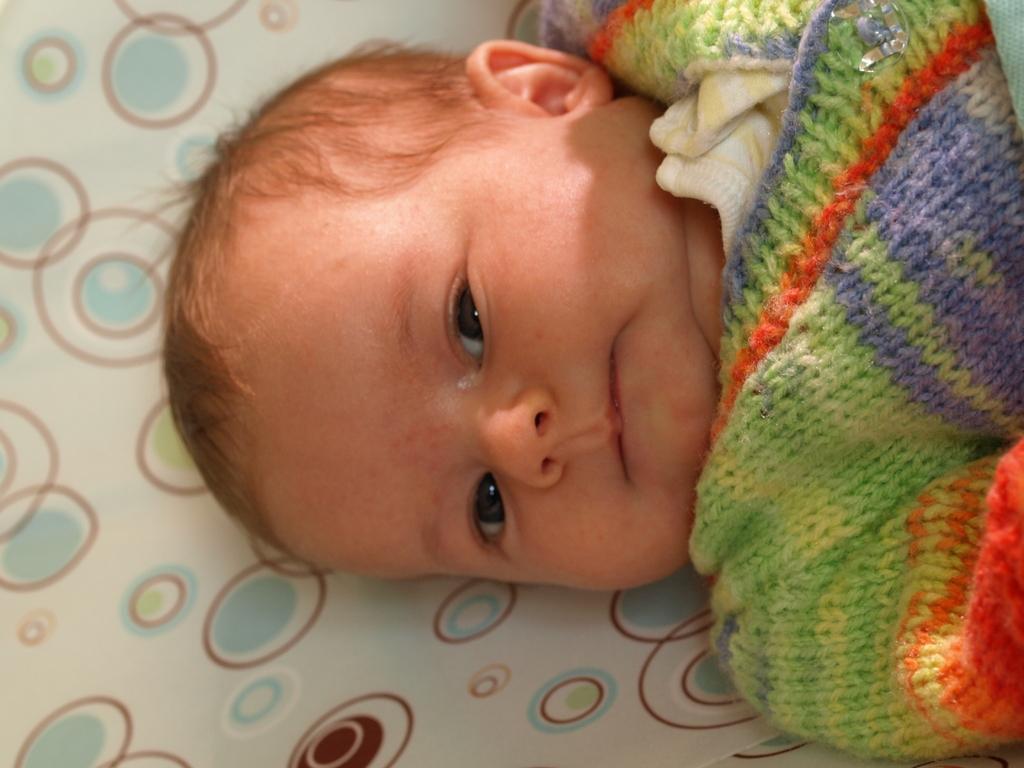Could you give a brief overview of what you see in this image? In this image there is one baby who is sleeping on bed. 